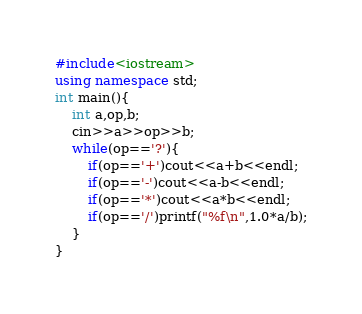<code> <loc_0><loc_0><loc_500><loc_500><_C++_>#include<iostream>
using namespace std;
int main(){
	int a,op,b;
	cin>>a>>op>>b;
	while(op=='?'){
	    if(op=='+')cout<<a+b<<endl;
	    if(op=='-')cout<<a-b<<endl;
	    if(op=='*')cout<<a*b<<endl;
	    if(op=='/')printf("%f\n",1.0*a/b);
	}
}

</code> 